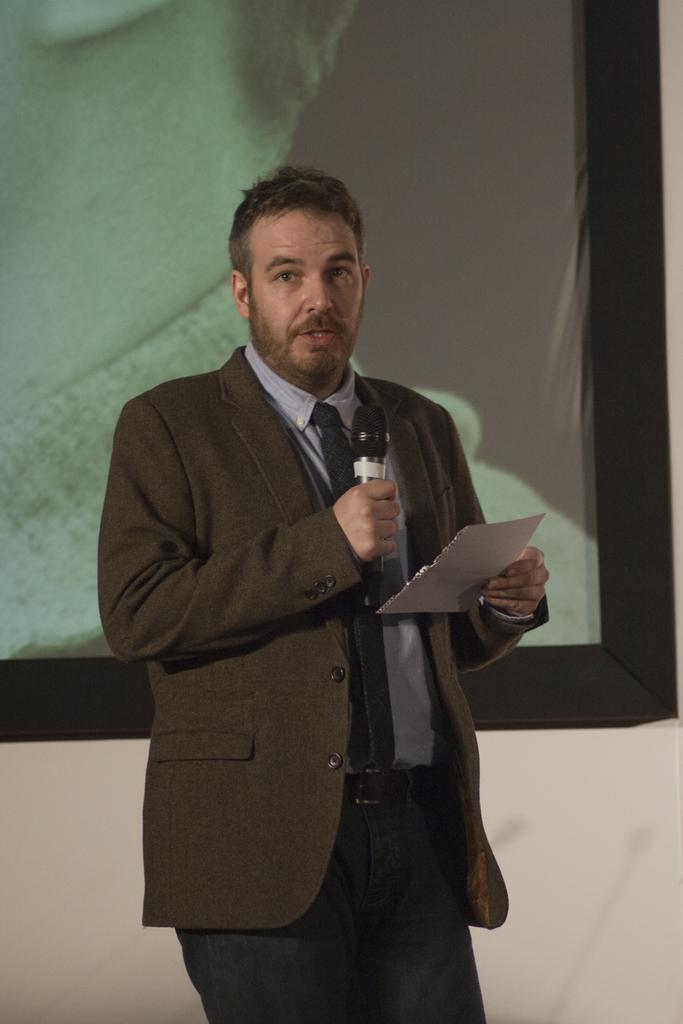Could you give a brief overview of what you see in this image? In this image, In the middle there is a man he wear suit, shirt, trouser and tie he hold a paper and mic, he is speaking. In the background there is a screen. 